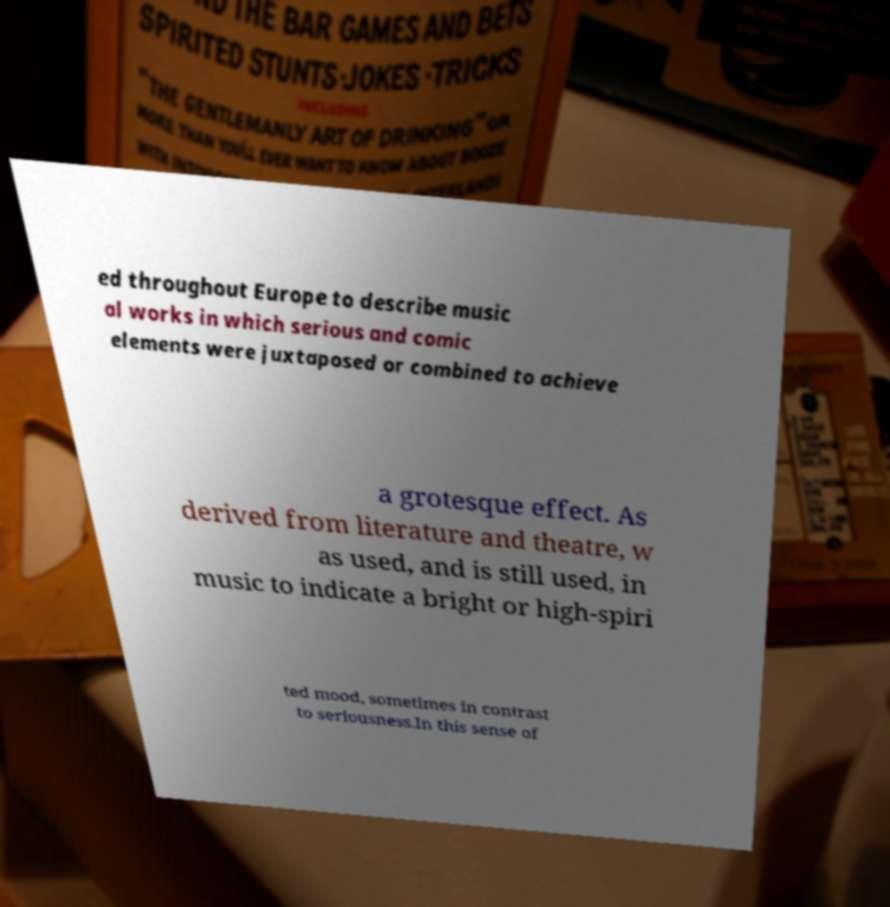Can you accurately transcribe the text from the provided image for me? ed throughout Europe to describe music al works in which serious and comic elements were juxtaposed or combined to achieve a grotesque effect. As derived from literature and theatre, w as used, and is still used, in music to indicate a bright or high-spiri ted mood, sometimes in contrast to seriousness.In this sense of 